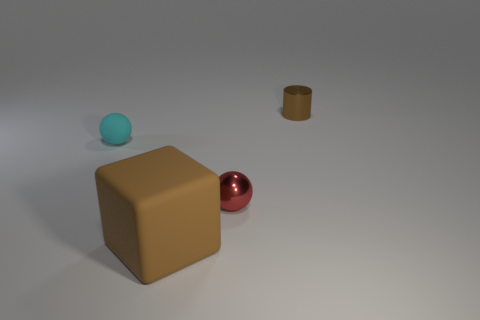Subtract all cyan balls. How many balls are left? 1 Add 2 purple objects. How many objects exist? 6 Subtract all gray objects. Subtract all tiny brown cylinders. How many objects are left? 3 Add 3 small cyan matte objects. How many small cyan matte objects are left? 4 Add 4 tiny cyan spheres. How many tiny cyan spheres exist? 5 Subtract 0 red cylinders. How many objects are left? 4 Subtract all cylinders. How many objects are left? 3 Subtract all blue cubes. Subtract all purple cylinders. How many cubes are left? 1 Subtract all blue balls. How many gray blocks are left? 0 